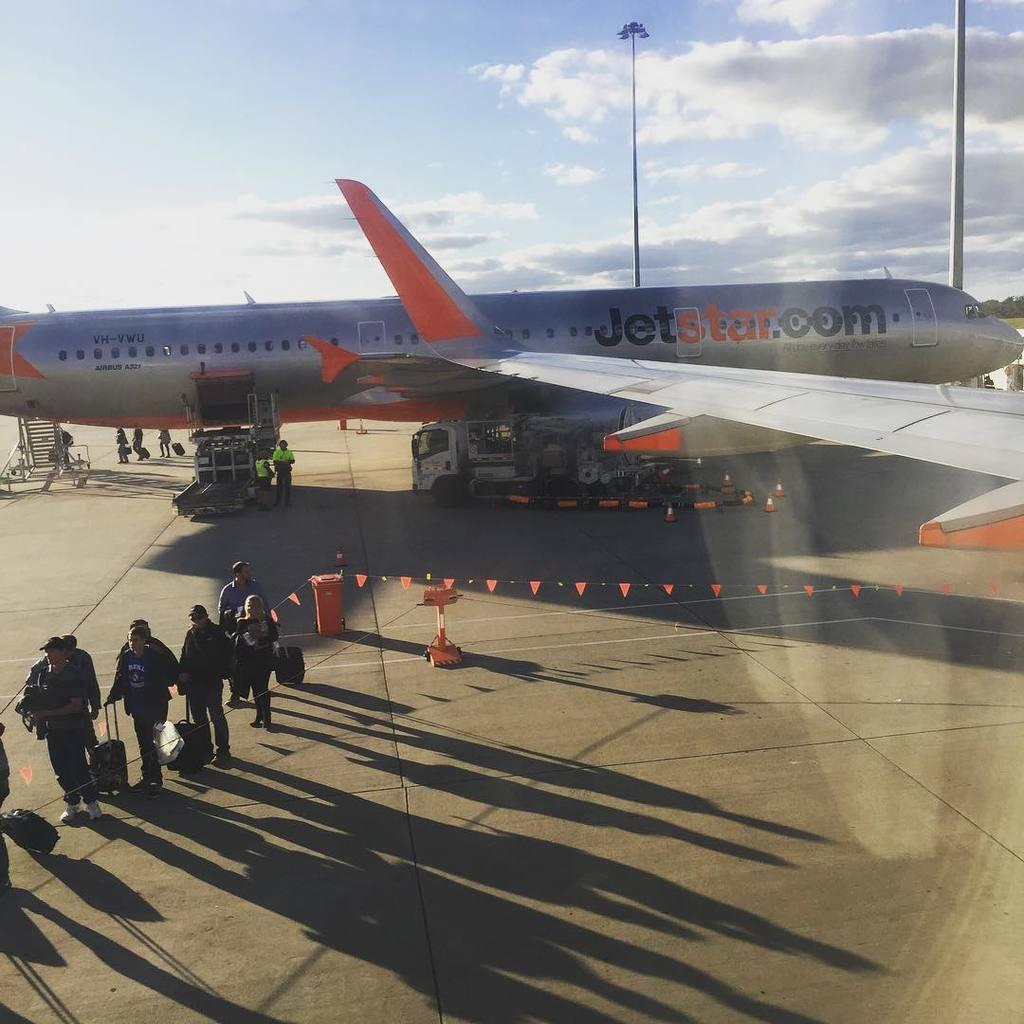<image>
Summarize the visual content of the image. People walk away from a Jetstar plane at the airport. 